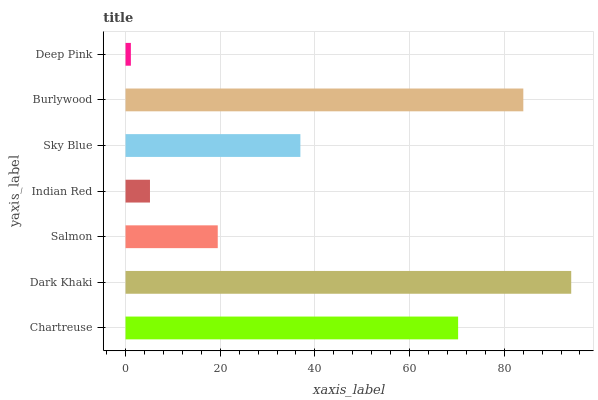Is Deep Pink the minimum?
Answer yes or no. Yes. Is Dark Khaki the maximum?
Answer yes or no. Yes. Is Salmon the minimum?
Answer yes or no. No. Is Salmon the maximum?
Answer yes or no. No. Is Dark Khaki greater than Salmon?
Answer yes or no. Yes. Is Salmon less than Dark Khaki?
Answer yes or no. Yes. Is Salmon greater than Dark Khaki?
Answer yes or no. No. Is Dark Khaki less than Salmon?
Answer yes or no. No. Is Sky Blue the high median?
Answer yes or no. Yes. Is Sky Blue the low median?
Answer yes or no. Yes. Is Deep Pink the high median?
Answer yes or no. No. Is Burlywood the low median?
Answer yes or no. No. 